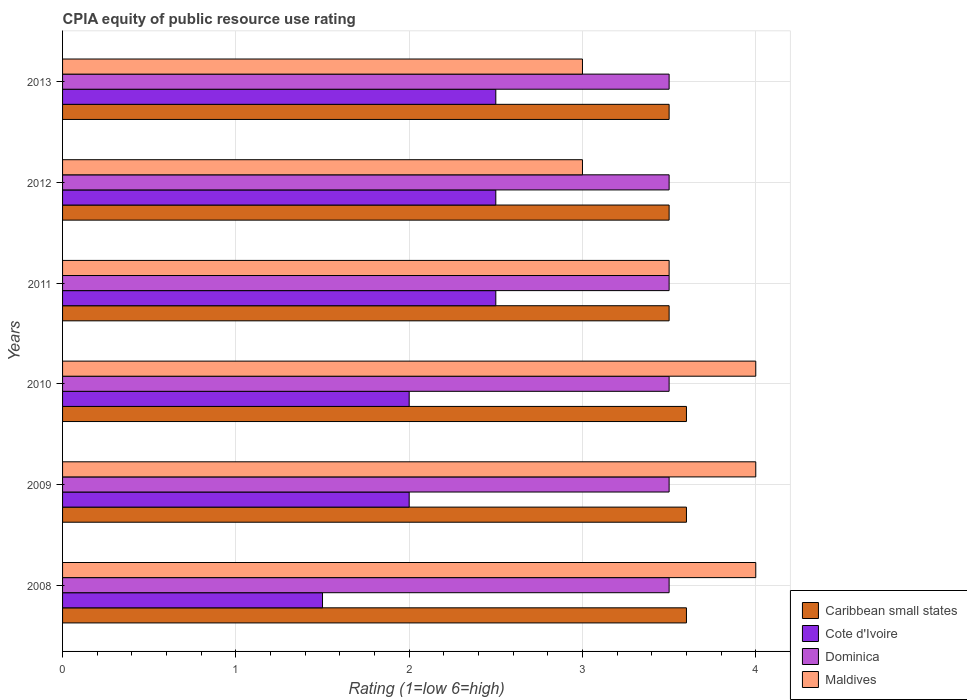How many different coloured bars are there?
Your answer should be compact. 4. Are the number of bars per tick equal to the number of legend labels?
Make the answer very short. Yes. Are the number of bars on each tick of the Y-axis equal?
Your response must be concise. Yes. How many bars are there on the 2nd tick from the top?
Give a very brief answer. 4. How many bars are there on the 3rd tick from the bottom?
Offer a terse response. 4. In how many cases, is the number of bars for a given year not equal to the number of legend labels?
Ensure brevity in your answer.  0. In which year was the CPIA rating in Caribbean small states maximum?
Offer a terse response. 2008. What is the difference between the CPIA rating in Caribbean small states in 2008 and that in 2012?
Keep it short and to the point. 0.1. What is the difference between the CPIA rating in Dominica in 2008 and the CPIA rating in Caribbean small states in 2013?
Your answer should be very brief. 0. What is the average CPIA rating in Cote d'Ivoire per year?
Offer a terse response. 2.17. In the year 2009, what is the difference between the CPIA rating in Dominica and CPIA rating in Caribbean small states?
Your answer should be very brief. -0.1. What is the ratio of the CPIA rating in Dominica in 2012 to that in 2013?
Give a very brief answer. 1. Is the CPIA rating in Cote d'Ivoire in 2009 less than that in 2011?
Your answer should be compact. Yes. What is the difference between the highest and the lowest CPIA rating in Cote d'Ivoire?
Keep it short and to the point. 1. Is it the case that in every year, the sum of the CPIA rating in Maldives and CPIA rating in Dominica is greater than the sum of CPIA rating in Cote d'Ivoire and CPIA rating in Caribbean small states?
Provide a succinct answer. No. What does the 2nd bar from the top in 2010 represents?
Your answer should be compact. Dominica. What does the 4th bar from the bottom in 2011 represents?
Provide a succinct answer. Maldives. Is it the case that in every year, the sum of the CPIA rating in Cote d'Ivoire and CPIA rating in Caribbean small states is greater than the CPIA rating in Maldives?
Offer a very short reply. Yes. Are all the bars in the graph horizontal?
Your answer should be compact. Yes. How many legend labels are there?
Provide a succinct answer. 4. How are the legend labels stacked?
Offer a very short reply. Vertical. What is the title of the graph?
Offer a very short reply. CPIA equity of public resource use rating. Does "Kuwait" appear as one of the legend labels in the graph?
Offer a terse response. No. What is the label or title of the Y-axis?
Make the answer very short. Years. What is the Rating (1=low 6=high) of Maldives in 2008?
Offer a very short reply. 4. What is the Rating (1=low 6=high) in Caribbean small states in 2009?
Offer a very short reply. 3.6. What is the Rating (1=low 6=high) in Dominica in 2009?
Offer a terse response. 3.5. What is the Rating (1=low 6=high) in Caribbean small states in 2010?
Your answer should be very brief. 3.6. What is the Rating (1=low 6=high) of Cote d'Ivoire in 2010?
Provide a succinct answer. 2. What is the Rating (1=low 6=high) of Maldives in 2010?
Your answer should be very brief. 4. What is the Rating (1=low 6=high) in Cote d'Ivoire in 2011?
Your answer should be very brief. 2.5. What is the Rating (1=low 6=high) of Dominica in 2011?
Your answer should be very brief. 3.5. What is the Rating (1=low 6=high) of Dominica in 2012?
Offer a terse response. 3.5. What is the Rating (1=low 6=high) of Maldives in 2012?
Your response must be concise. 3. What is the Rating (1=low 6=high) in Caribbean small states in 2013?
Provide a short and direct response. 3.5. What is the Rating (1=low 6=high) in Maldives in 2013?
Give a very brief answer. 3. Across all years, what is the maximum Rating (1=low 6=high) in Cote d'Ivoire?
Your answer should be compact. 2.5. Across all years, what is the minimum Rating (1=low 6=high) of Caribbean small states?
Keep it short and to the point. 3.5. Across all years, what is the minimum Rating (1=low 6=high) in Dominica?
Keep it short and to the point. 3.5. Across all years, what is the minimum Rating (1=low 6=high) in Maldives?
Give a very brief answer. 3. What is the total Rating (1=low 6=high) in Caribbean small states in the graph?
Your answer should be compact. 21.3. What is the difference between the Rating (1=low 6=high) of Caribbean small states in 2008 and that in 2009?
Provide a succinct answer. 0. What is the difference between the Rating (1=low 6=high) of Dominica in 2008 and that in 2009?
Provide a short and direct response. 0. What is the difference between the Rating (1=low 6=high) in Maldives in 2008 and that in 2009?
Provide a succinct answer. 0. What is the difference between the Rating (1=low 6=high) in Cote d'Ivoire in 2008 and that in 2010?
Provide a short and direct response. -0.5. What is the difference between the Rating (1=low 6=high) in Maldives in 2008 and that in 2010?
Offer a very short reply. 0. What is the difference between the Rating (1=low 6=high) in Caribbean small states in 2008 and that in 2011?
Keep it short and to the point. 0.1. What is the difference between the Rating (1=low 6=high) of Cote d'Ivoire in 2008 and that in 2011?
Provide a succinct answer. -1. What is the difference between the Rating (1=low 6=high) in Dominica in 2008 and that in 2011?
Your response must be concise. 0. What is the difference between the Rating (1=low 6=high) of Cote d'Ivoire in 2008 and that in 2012?
Provide a succinct answer. -1. What is the difference between the Rating (1=low 6=high) of Dominica in 2008 and that in 2012?
Ensure brevity in your answer.  0. What is the difference between the Rating (1=low 6=high) in Caribbean small states in 2008 and that in 2013?
Your response must be concise. 0.1. What is the difference between the Rating (1=low 6=high) of Maldives in 2008 and that in 2013?
Ensure brevity in your answer.  1. What is the difference between the Rating (1=low 6=high) in Caribbean small states in 2009 and that in 2010?
Your answer should be very brief. 0. What is the difference between the Rating (1=low 6=high) in Dominica in 2009 and that in 2010?
Make the answer very short. 0. What is the difference between the Rating (1=low 6=high) in Caribbean small states in 2009 and that in 2011?
Your answer should be very brief. 0.1. What is the difference between the Rating (1=low 6=high) of Cote d'Ivoire in 2009 and that in 2011?
Your answer should be very brief. -0.5. What is the difference between the Rating (1=low 6=high) in Dominica in 2009 and that in 2011?
Offer a terse response. 0. What is the difference between the Rating (1=low 6=high) in Cote d'Ivoire in 2009 and that in 2013?
Your answer should be compact. -0.5. What is the difference between the Rating (1=low 6=high) in Dominica in 2009 and that in 2013?
Provide a succinct answer. 0. What is the difference between the Rating (1=low 6=high) in Caribbean small states in 2010 and that in 2011?
Give a very brief answer. 0.1. What is the difference between the Rating (1=low 6=high) in Cote d'Ivoire in 2010 and that in 2011?
Keep it short and to the point. -0.5. What is the difference between the Rating (1=low 6=high) in Cote d'Ivoire in 2010 and that in 2012?
Offer a very short reply. -0.5. What is the difference between the Rating (1=low 6=high) in Dominica in 2010 and that in 2012?
Provide a short and direct response. 0. What is the difference between the Rating (1=low 6=high) in Maldives in 2010 and that in 2012?
Keep it short and to the point. 1. What is the difference between the Rating (1=low 6=high) in Cote d'Ivoire in 2010 and that in 2013?
Your answer should be compact. -0.5. What is the difference between the Rating (1=low 6=high) of Dominica in 2010 and that in 2013?
Your response must be concise. 0. What is the difference between the Rating (1=low 6=high) of Dominica in 2011 and that in 2013?
Offer a very short reply. 0. What is the difference between the Rating (1=low 6=high) in Maldives in 2011 and that in 2013?
Your response must be concise. 0.5. What is the difference between the Rating (1=low 6=high) in Cote d'Ivoire in 2012 and that in 2013?
Provide a succinct answer. 0. What is the difference between the Rating (1=low 6=high) in Dominica in 2012 and that in 2013?
Your response must be concise. 0. What is the difference between the Rating (1=low 6=high) in Caribbean small states in 2008 and the Rating (1=low 6=high) in Cote d'Ivoire in 2009?
Your answer should be very brief. 1.6. What is the difference between the Rating (1=low 6=high) in Dominica in 2008 and the Rating (1=low 6=high) in Maldives in 2009?
Provide a succinct answer. -0.5. What is the difference between the Rating (1=low 6=high) in Caribbean small states in 2008 and the Rating (1=low 6=high) in Cote d'Ivoire in 2010?
Give a very brief answer. 1.6. What is the difference between the Rating (1=low 6=high) of Caribbean small states in 2008 and the Rating (1=low 6=high) of Dominica in 2010?
Provide a succinct answer. 0.1. What is the difference between the Rating (1=low 6=high) of Cote d'Ivoire in 2008 and the Rating (1=low 6=high) of Dominica in 2010?
Make the answer very short. -2. What is the difference between the Rating (1=low 6=high) in Cote d'Ivoire in 2008 and the Rating (1=low 6=high) in Maldives in 2010?
Offer a very short reply. -2.5. What is the difference between the Rating (1=low 6=high) in Dominica in 2008 and the Rating (1=low 6=high) in Maldives in 2010?
Offer a terse response. -0.5. What is the difference between the Rating (1=low 6=high) in Caribbean small states in 2008 and the Rating (1=low 6=high) in Cote d'Ivoire in 2011?
Your response must be concise. 1.1. What is the difference between the Rating (1=low 6=high) of Caribbean small states in 2008 and the Rating (1=low 6=high) of Maldives in 2011?
Your answer should be compact. 0.1. What is the difference between the Rating (1=low 6=high) of Cote d'Ivoire in 2008 and the Rating (1=low 6=high) of Dominica in 2011?
Your answer should be compact. -2. What is the difference between the Rating (1=low 6=high) in Cote d'Ivoire in 2008 and the Rating (1=low 6=high) in Maldives in 2011?
Your response must be concise. -2. What is the difference between the Rating (1=low 6=high) in Caribbean small states in 2008 and the Rating (1=low 6=high) in Maldives in 2012?
Provide a succinct answer. 0.6. What is the difference between the Rating (1=low 6=high) of Dominica in 2008 and the Rating (1=low 6=high) of Maldives in 2012?
Provide a succinct answer. 0.5. What is the difference between the Rating (1=low 6=high) of Caribbean small states in 2008 and the Rating (1=low 6=high) of Cote d'Ivoire in 2013?
Keep it short and to the point. 1.1. What is the difference between the Rating (1=low 6=high) of Caribbean small states in 2008 and the Rating (1=low 6=high) of Dominica in 2013?
Offer a terse response. 0.1. What is the difference between the Rating (1=low 6=high) of Caribbean small states in 2008 and the Rating (1=low 6=high) of Maldives in 2013?
Give a very brief answer. 0.6. What is the difference between the Rating (1=low 6=high) of Dominica in 2008 and the Rating (1=low 6=high) of Maldives in 2013?
Provide a succinct answer. 0.5. What is the difference between the Rating (1=low 6=high) of Caribbean small states in 2009 and the Rating (1=low 6=high) of Maldives in 2010?
Make the answer very short. -0.4. What is the difference between the Rating (1=low 6=high) in Cote d'Ivoire in 2009 and the Rating (1=low 6=high) in Dominica in 2010?
Provide a succinct answer. -1.5. What is the difference between the Rating (1=low 6=high) in Cote d'Ivoire in 2009 and the Rating (1=low 6=high) in Maldives in 2010?
Your answer should be compact. -2. What is the difference between the Rating (1=low 6=high) of Cote d'Ivoire in 2009 and the Rating (1=low 6=high) of Maldives in 2011?
Provide a succinct answer. -1.5. What is the difference between the Rating (1=low 6=high) in Caribbean small states in 2009 and the Rating (1=low 6=high) in Dominica in 2013?
Make the answer very short. 0.1. What is the difference between the Rating (1=low 6=high) in Cote d'Ivoire in 2009 and the Rating (1=low 6=high) in Maldives in 2013?
Provide a short and direct response. -1. What is the difference between the Rating (1=low 6=high) in Dominica in 2009 and the Rating (1=low 6=high) in Maldives in 2013?
Give a very brief answer. 0.5. What is the difference between the Rating (1=low 6=high) of Caribbean small states in 2010 and the Rating (1=low 6=high) of Cote d'Ivoire in 2012?
Make the answer very short. 1.1. What is the difference between the Rating (1=low 6=high) in Caribbean small states in 2010 and the Rating (1=low 6=high) in Dominica in 2012?
Make the answer very short. 0.1. What is the difference between the Rating (1=low 6=high) in Cote d'Ivoire in 2010 and the Rating (1=low 6=high) in Dominica in 2012?
Your answer should be very brief. -1.5. What is the difference between the Rating (1=low 6=high) of Caribbean small states in 2010 and the Rating (1=low 6=high) of Dominica in 2013?
Your answer should be very brief. 0.1. What is the difference between the Rating (1=low 6=high) of Caribbean small states in 2010 and the Rating (1=low 6=high) of Maldives in 2013?
Provide a short and direct response. 0.6. What is the difference between the Rating (1=low 6=high) in Cote d'Ivoire in 2010 and the Rating (1=low 6=high) in Dominica in 2013?
Your response must be concise. -1.5. What is the difference between the Rating (1=low 6=high) of Dominica in 2010 and the Rating (1=low 6=high) of Maldives in 2013?
Make the answer very short. 0.5. What is the difference between the Rating (1=low 6=high) of Dominica in 2011 and the Rating (1=low 6=high) of Maldives in 2012?
Give a very brief answer. 0.5. What is the difference between the Rating (1=low 6=high) in Caribbean small states in 2011 and the Rating (1=low 6=high) in Cote d'Ivoire in 2013?
Your response must be concise. 1. What is the difference between the Rating (1=low 6=high) in Cote d'Ivoire in 2011 and the Rating (1=low 6=high) in Maldives in 2013?
Make the answer very short. -0.5. What is the difference between the Rating (1=low 6=high) of Caribbean small states in 2012 and the Rating (1=low 6=high) of Cote d'Ivoire in 2013?
Your response must be concise. 1. What is the difference between the Rating (1=low 6=high) in Cote d'Ivoire in 2012 and the Rating (1=low 6=high) in Dominica in 2013?
Your answer should be very brief. -1. What is the difference between the Rating (1=low 6=high) in Dominica in 2012 and the Rating (1=low 6=high) in Maldives in 2013?
Ensure brevity in your answer.  0.5. What is the average Rating (1=low 6=high) of Caribbean small states per year?
Give a very brief answer. 3.55. What is the average Rating (1=low 6=high) in Cote d'Ivoire per year?
Make the answer very short. 2.17. What is the average Rating (1=low 6=high) of Dominica per year?
Provide a short and direct response. 3.5. What is the average Rating (1=low 6=high) in Maldives per year?
Provide a short and direct response. 3.58. In the year 2008, what is the difference between the Rating (1=low 6=high) in Caribbean small states and Rating (1=low 6=high) in Maldives?
Ensure brevity in your answer.  -0.4. In the year 2008, what is the difference between the Rating (1=low 6=high) in Cote d'Ivoire and Rating (1=low 6=high) in Dominica?
Offer a terse response. -2. In the year 2008, what is the difference between the Rating (1=low 6=high) in Dominica and Rating (1=low 6=high) in Maldives?
Make the answer very short. -0.5. In the year 2009, what is the difference between the Rating (1=low 6=high) of Caribbean small states and Rating (1=low 6=high) of Maldives?
Give a very brief answer. -0.4. In the year 2009, what is the difference between the Rating (1=low 6=high) in Cote d'Ivoire and Rating (1=low 6=high) in Dominica?
Provide a succinct answer. -1.5. In the year 2010, what is the difference between the Rating (1=low 6=high) in Caribbean small states and Rating (1=low 6=high) in Dominica?
Ensure brevity in your answer.  0.1. In the year 2010, what is the difference between the Rating (1=low 6=high) of Caribbean small states and Rating (1=low 6=high) of Maldives?
Offer a very short reply. -0.4. In the year 2010, what is the difference between the Rating (1=low 6=high) of Cote d'Ivoire and Rating (1=low 6=high) of Dominica?
Make the answer very short. -1.5. In the year 2011, what is the difference between the Rating (1=low 6=high) of Caribbean small states and Rating (1=low 6=high) of Cote d'Ivoire?
Keep it short and to the point. 1. In the year 2011, what is the difference between the Rating (1=low 6=high) in Caribbean small states and Rating (1=low 6=high) in Dominica?
Provide a short and direct response. 0. In the year 2011, what is the difference between the Rating (1=low 6=high) in Caribbean small states and Rating (1=low 6=high) in Maldives?
Make the answer very short. 0. In the year 2012, what is the difference between the Rating (1=low 6=high) in Caribbean small states and Rating (1=low 6=high) in Cote d'Ivoire?
Offer a terse response. 1. In the year 2012, what is the difference between the Rating (1=low 6=high) in Cote d'Ivoire and Rating (1=low 6=high) in Dominica?
Your answer should be compact. -1. In the year 2012, what is the difference between the Rating (1=low 6=high) of Cote d'Ivoire and Rating (1=low 6=high) of Maldives?
Your answer should be compact. -0.5. In the year 2012, what is the difference between the Rating (1=low 6=high) of Dominica and Rating (1=low 6=high) of Maldives?
Your answer should be very brief. 0.5. In the year 2013, what is the difference between the Rating (1=low 6=high) of Caribbean small states and Rating (1=low 6=high) of Maldives?
Your response must be concise. 0.5. In the year 2013, what is the difference between the Rating (1=low 6=high) of Cote d'Ivoire and Rating (1=low 6=high) of Dominica?
Offer a terse response. -1. In the year 2013, what is the difference between the Rating (1=low 6=high) in Dominica and Rating (1=low 6=high) in Maldives?
Offer a very short reply. 0.5. What is the ratio of the Rating (1=low 6=high) in Caribbean small states in 2008 to that in 2009?
Give a very brief answer. 1. What is the ratio of the Rating (1=low 6=high) of Cote d'Ivoire in 2008 to that in 2009?
Offer a very short reply. 0.75. What is the ratio of the Rating (1=low 6=high) in Caribbean small states in 2008 to that in 2010?
Provide a succinct answer. 1. What is the ratio of the Rating (1=low 6=high) of Cote d'Ivoire in 2008 to that in 2010?
Make the answer very short. 0.75. What is the ratio of the Rating (1=low 6=high) of Dominica in 2008 to that in 2010?
Offer a terse response. 1. What is the ratio of the Rating (1=low 6=high) in Maldives in 2008 to that in 2010?
Offer a very short reply. 1. What is the ratio of the Rating (1=low 6=high) of Caribbean small states in 2008 to that in 2011?
Offer a terse response. 1.03. What is the ratio of the Rating (1=low 6=high) of Dominica in 2008 to that in 2011?
Keep it short and to the point. 1. What is the ratio of the Rating (1=low 6=high) of Caribbean small states in 2008 to that in 2012?
Offer a very short reply. 1.03. What is the ratio of the Rating (1=low 6=high) of Dominica in 2008 to that in 2012?
Provide a succinct answer. 1. What is the ratio of the Rating (1=low 6=high) in Caribbean small states in 2008 to that in 2013?
Offer a terse response. 1.03. What is the ratio of the Rating (1=low 6=high) in Cote d'Ivoire in 2008 to that in 2013?
Provide a short and direct response. 0.6. What is the ratio of the Rating (1=low 6=high) of Dominica in 2008 to that in 2013?
Keep it short and to the point. 1. What is the ratio of the Rating (1=low 6=high) of Maldives in 2008 to that in 2013?
Ensure brevity in your answer.  1.33. What is the ratio of the Rating (1=low 6=high) in Caribbean small states in 2009 to that in 2010?
Your answer should be compact. 1. What is the ratio of the Rating (1=low 6=high) of Caribbean small states in 2009 to that in 2011?
Ensure brevity in your answer.  1.03. What is the ratio of the Rating (1=low 6=high) of Cote d'Ivoire in 2009 to that in 2011?
Your response must be concise. 0.8. What is the ratio of the Rating (1=low 6=high) in Dominica in 2009 to that in 2011?
Your response must be concise. 1. What is the ratio of the Rating (1=low 6=high) of Caribbean small states in 2009 to that in 2012?
Make the answer very short. 1.03. What is the ratio of the Rating (1=low 6=high) in Caribbean small states in 2009 to that in 2013?
Make the answer very short. 1.03. What is the ratio of the Rating (1=low 6=high) in Caribbean small states in 2010 to that in 2011?
Offer a very short reply. 1.03. What is the ratio of the Rating (1=low 6=high) in Dominica in 2010 to that in 2011?
Keep it short and to the point. 1. What is the ratio of the Rating (1=low 6=high) of Maldives in 2010 to that in 2011?
Provide a short and direct response. 1.14. What is the ratio of the Rating (1=low 6=high) of Caribbean small states in 2010 to that in 2012?
Offer a terse response. 1.03. What is the ratio of the Rating (1=low 6=high) of Maldives in 2010 to that in 2012?
Ensure brevity in your answer.  1.33. What is the ratio of the Rating (1=low 6=high) in Caribbean small states in 2010 to that in 2013?
Your answer should be compact. 1.03. What is the ratio of the Rating (1=low 6=high) in Dominica in 2010 to that in 2013?
Your response must be concise. 1. What is the ratio of the Rating (1=low 6=high) in Caribbean small states in 2011 to that in 2012?
Your response must be concise. 1. What is the ratio of the Rating (1=low 6=high) in Cote d'Ivoire in 2011 to that in 2012?
Offer a terse response. 1. What is the ratio of the Rating (1=low 6=high) in Maldives in 2011 to that in 2012?
Keep it short and to the point. 1.17. What is the ratio of the Rating (1=low 6=high) in Cote d'Ivoire in 2011 to that in 2013?
Your response must be concise. 1. What is the ratio of the Rating (1=low 6=high) in Dominica in 2011 to that in 2013?
Keep it short and to the point. 1. What is the ratio of the Rating (1=low 6=high) in Maldives in 2011 to that in 2013?
Give a very brief answer. 1.17. What is the ratio of the Rating (1=low 6=high) of Caribbean small states in 2012 to that in 2013?
Give a very brief answer. 1. What is the ratio of the Rating (1=low 6=high) of Dominica in 2012 to that in 2013?
Your answer should be very brief. 1. What is the ratio of the Rating (1=low 6=high) in Maldives in 2012 to that in 2013?
Keep it short and to the point. 1. What is the difference between the highest and the second highest Rating (1=low 6=high) in Caribbean small states?
Give a very brief answer. 0. What is the difference between the highest and the second highest Rating (1=low 6=high) of Dominica?
Your response must be concise. 0. What is the difference between the highest and the second highest Rating (1=low 6=high) in Maldives?
Your response must be concise. 0. What is the difference between the highest and the lowest Rating (1=low 6=high) of Caribbean small states?
Your answer should be compact. 0.1. What is the difference between the highest and the lowest Rating (1=low 6=high) of Cote d'Ivoire?
Your answer should be compact. 1. 